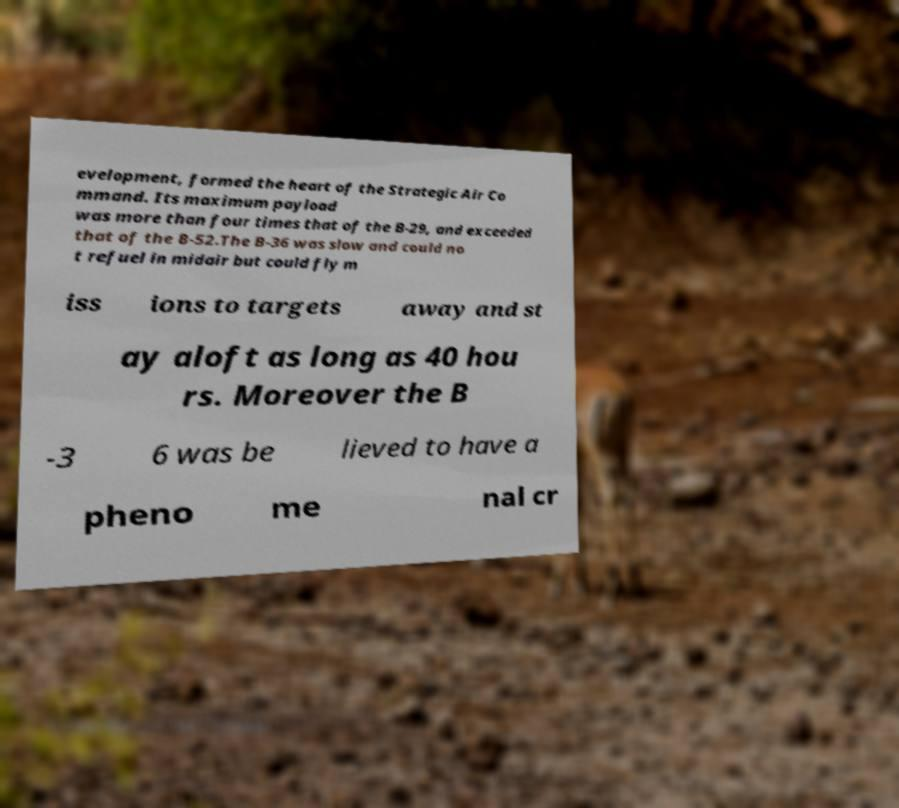What messages or text are displayed in this image? I need them in a readable, typed format. evelopment, formed the heart of the Strategic Air Co mmand. Its maximum payload was more than four times that of the B-29, and exceeded that of the B-52.The B-36 was slow and could no t refuel in midair but could fly m iss ions to targets away and st ay aloft as long as 40 hou rs. Moreover the B -3 6 was be lieved to have a pheno me nal cr 